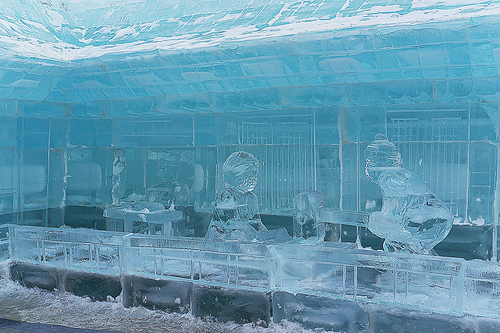<image>
Is there a icy kid above the ice platform? Yes. The icy kid is positioned above the ice platform in the vertical space, higher up in the scene. 